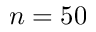Convert formula to latex. <formula><loc_0><loc_0><loc_500><loc_500>n = 5 0</formula> 